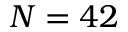Convert formula to latex. <formula><loc_0><loc_0><loc_500><loc_500>N = 4 2</formula> 